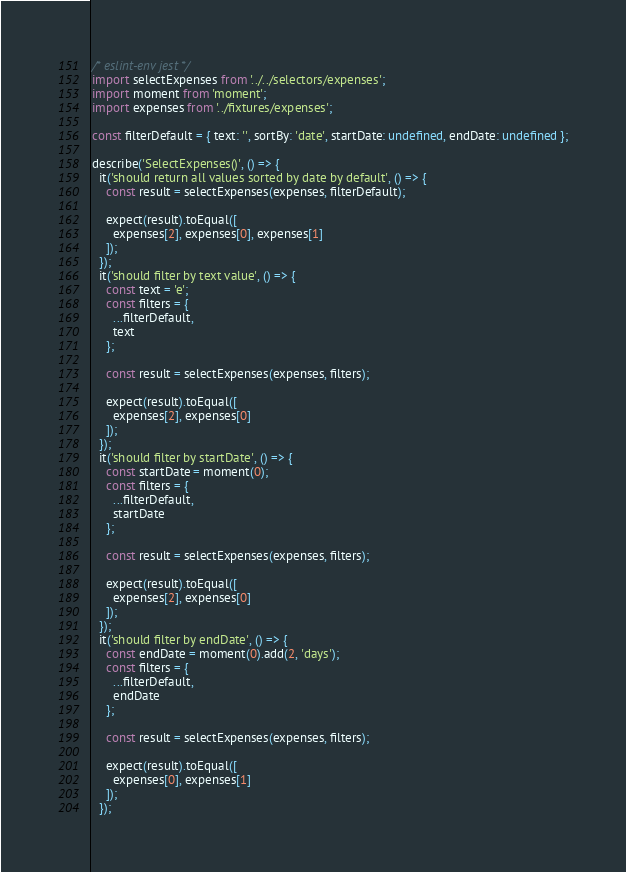Convert code to text. <code><loc_0><loc_0><loc_500><loc_500><_JavaScript_>
/* eslint-env jest */
import selectExpenses from '../../selectors/expenses';
import moment from 'moment';
import expenses from '../fixtures/expenses';

const filterDefault = { text: '', sortBy: 'date', startDate: undefined, endDate: undefined };

describe('SelectExpenses()', () => {
  it('should return all values sorted by date by default', () => {
    const result = selectExpenses(expenses, filterDefault);

    expect(result).toEqual([
      expenses[2], expenses[0], expenses[1]
    ]);
  });
  it('should filter by text value', () => {
    const text = 'e';
    const filters = {
      ...filterDefault,
      text
    };

    const result = selectExpenses(expenses, filters);

    expect(result).toEqual([
      expenses[2], expenses[0]
    ]);
  });
  it('should filter by startDate', () => {
    const startDate = moment(0);
    const filters = {
      ...filterDefault,
      startDate
    };

    const result = selectExpenses(expenses, filters);

    expect(result).toEqual([
      expenses[2], expenses[0]
    ]);
  });
  it('should filter by endDate', () => {
    const endDate = moment(0).add(2, 'days');
    const filters = {
      ...filterDefault,
      endDate
    };

    const result = selectExpenses(expenses, filters);

    expect(result).toEqual([
      expenses[0], expenses[1]
    ]);
  });</code> 